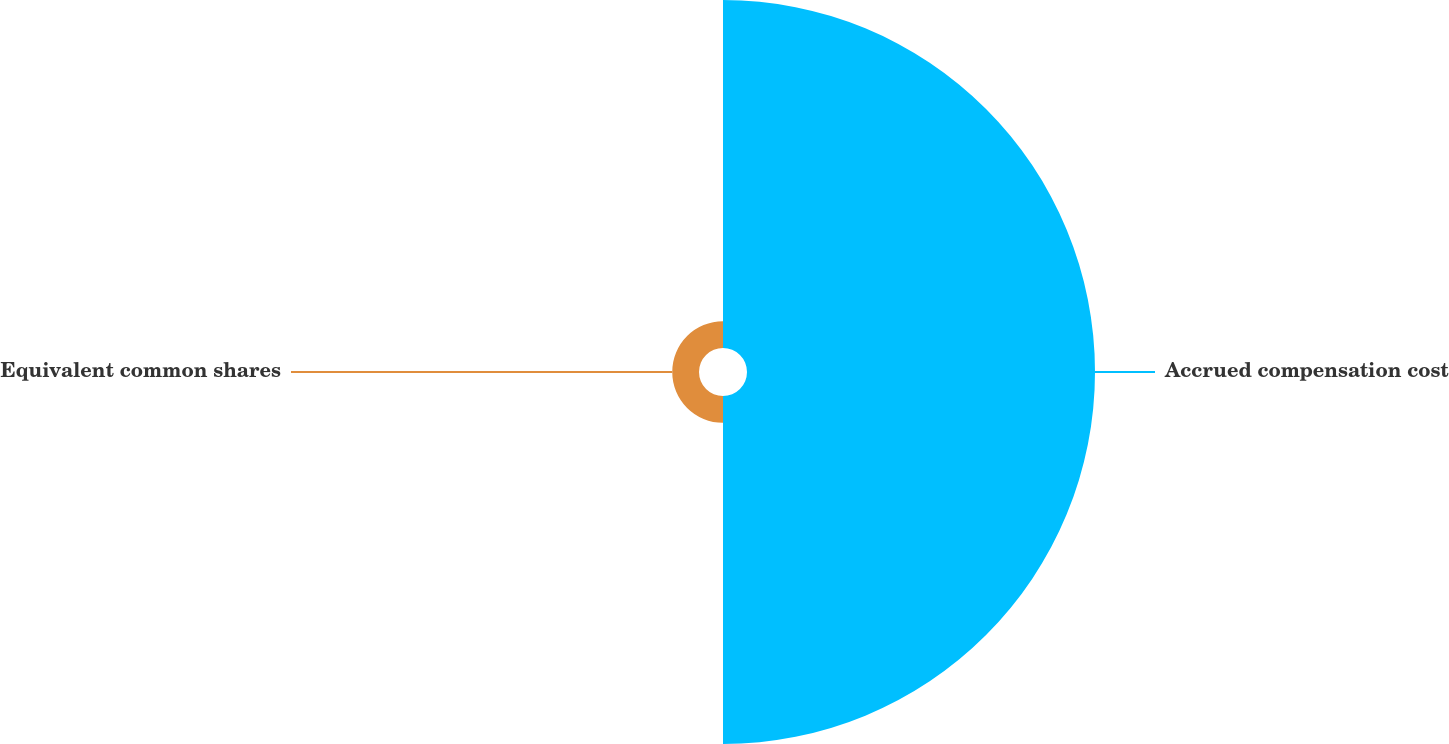<chart> <loc_0><loc_0><loc_500><loc_500><pie_chart><fcel>Accrued compensation cost<fcel>Equivalent common shares<nl><fcel>92.86%<fcel>7.14%<nl></chart> 